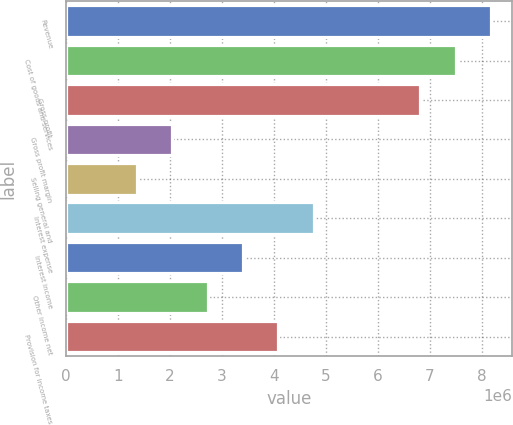Convert chart to OTSL. <chart><loc_0><loc_0><loc_500><loc_500><bar_chart><fcel>Revenue<fcel>Cost of goods and services<fcel>Gross profit<fcel>Gross profit margin<fcel>Selling general and<fcel>Interest expense<fcel>Interest income<fcel>Other income net<fcel>Provision for income taxes<nl><fcel>8.18506e+06<fcel>7.50297e+06<fcel>6.82089e+06<fcel>2.04627e+06<fcel>1.36418e+06<fcel>4.77462e+06<fcel>3.41045e+06<fcel>2.72836e+06<fcel>4.09253e+06<nl></chart> 